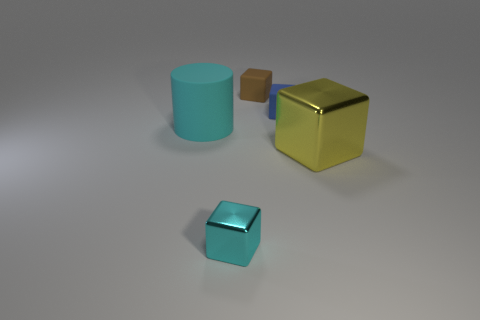How many other objects are the same material as the big cyan cylinder?
Keep it short and to the point. 2. Are the large object to the left of the large yellow metallic block and the block in front of the yellow shiny block made of the same material?
Your answer should be very brief. No. Are there the same number of cyan rubber cylinders on the right side of the small blue object and cyan metallic blocks that are behind the cyan metal cube?
Your answer should be very brief. Yes. What number of tiny things are the same color as the big shiny thing?
Your answer should be very brief. 0. There is a large object that is the same color as the tiny metal block; what material is it?
Provide a short and direct response. Rubber. What number of shiny things are green blocks or cylinders?
Offer a terse response. 0. Does the cyan object to the left of the tiny cyan shiny block have the same shape as the cyan object that is in front of the big yellow metal object?
Make the answer very short. No. There is a yellow object; what number of brown rubber things are right of it?
Your answer should be very brief. 0. Are there any large yellow things that have the same material as the blue thing?
Your answer should be very brief. No. What is the material of the yellow cube that is the same size as the cyan cylinder?
Provide a short and direct response. Metal. 